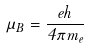Convert formula to latex. <formula><loc_0><loc_0><loc_500><loc_500>\mu _ { B } = \frac { e h } { 4 \pi m _ { e } }</formula> 